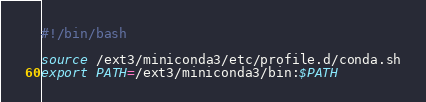<code> <loc_0><loc_0><loc_500><loc_500><_Bash_>#!/bin/bash

source /ext3/miniconda3/etc/profile.d/conda.sh
export PATH=/ext3/miniconda3/bin:$PATH</code> 